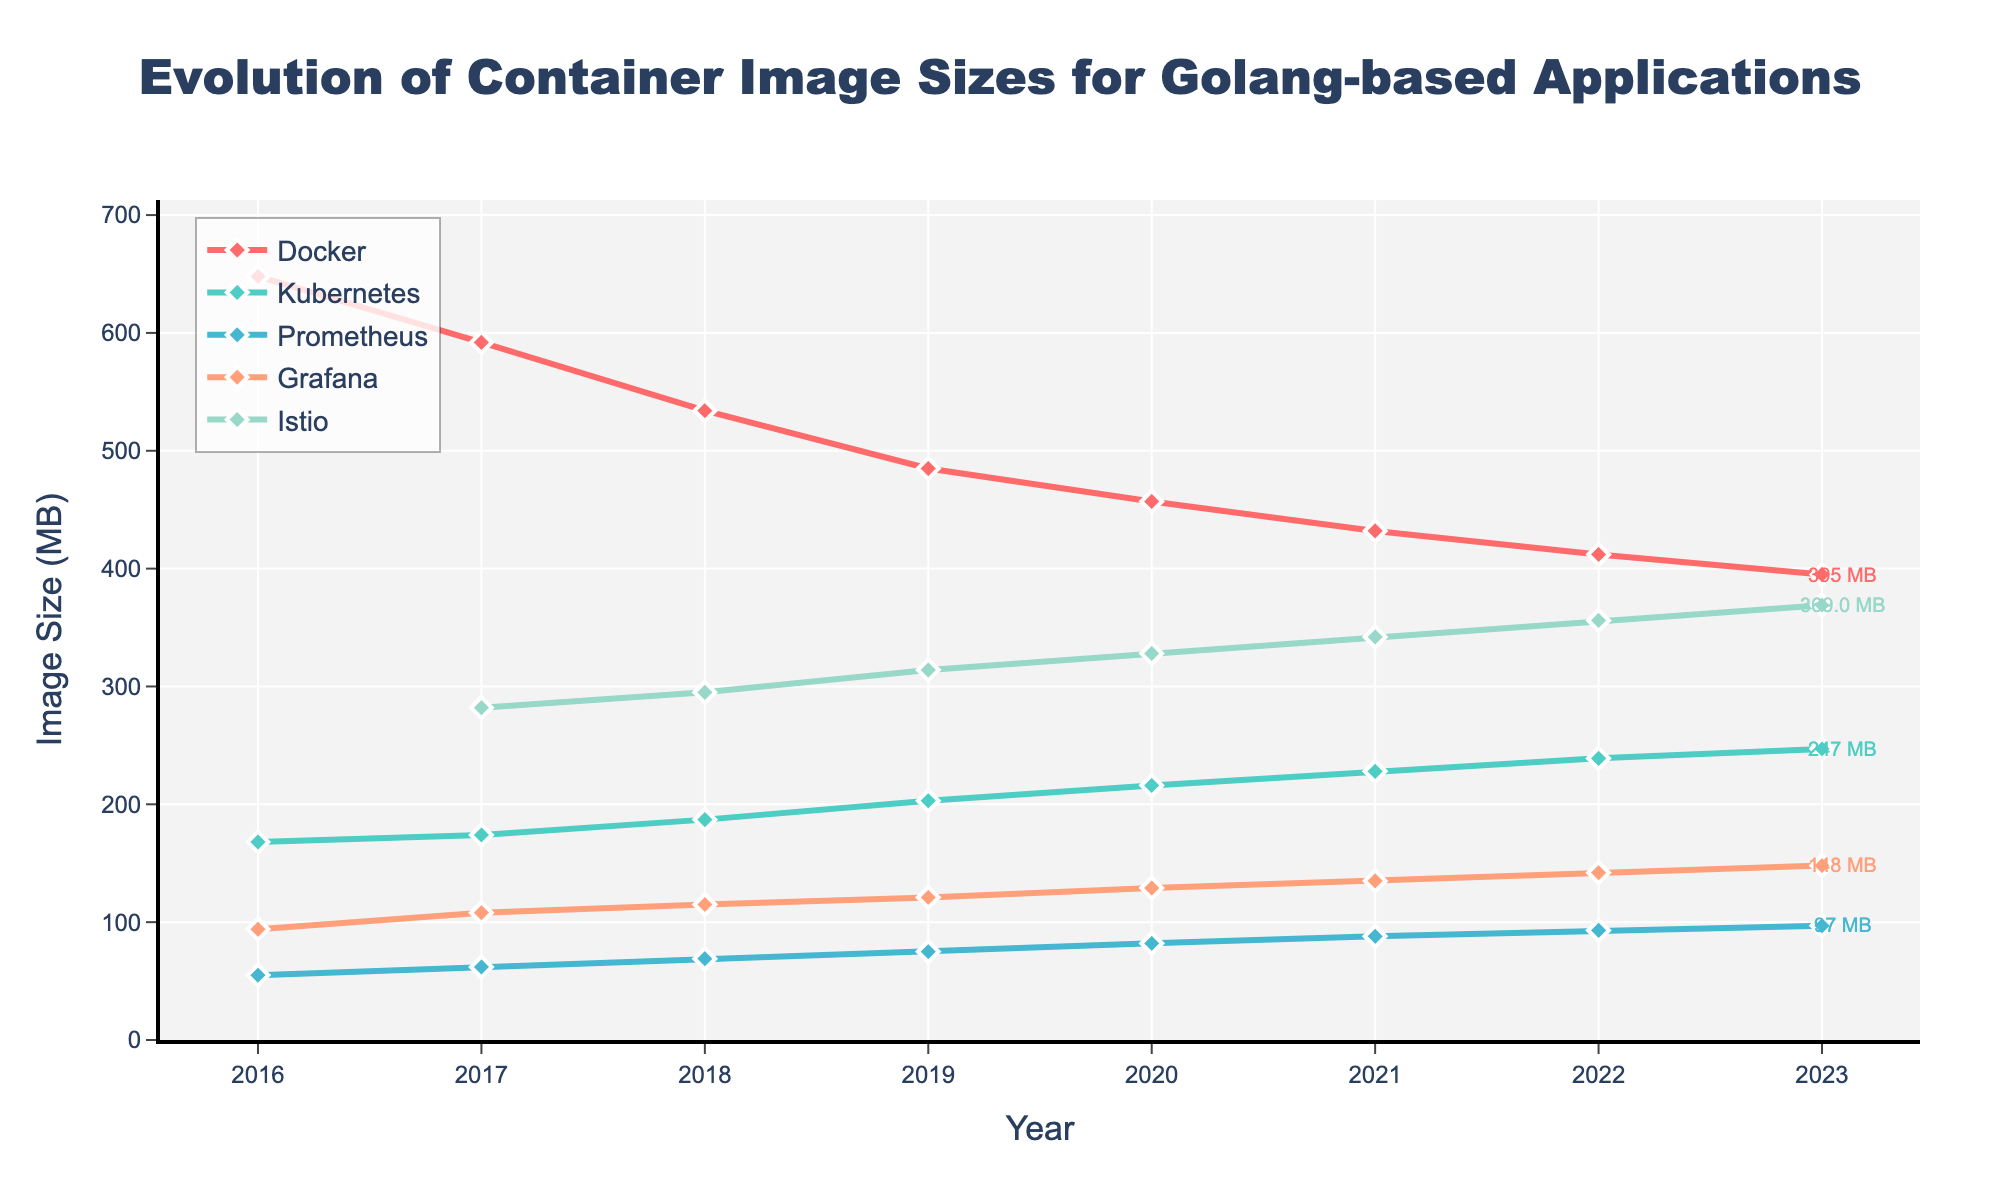Which application had the largest container image size in 2019? By looking at the plot, identify the highest point corresponding to the year 2019 across all applications. The application with the highest point in 2019 is Kubernetes with a size of 203 MB.
Answer: Kubernetes Has Docker's container image size increased or decreased from 2016 to 2023? Compare the position of Docker's line between the years 2016 and 2023. Docker's line shows a downward trend from 648 MB in 2016 to 395 MB in 2023.
Answer: Decreased In which year did Istio appear in the dataset, and what was its image size that year? Locate the first instance of Istio in the dataset by the starting point of the Istio line, which is in 2017 with an image size of 282 MB.
Answer: 2017, 282 MB Which Golang-based application had the smallest container image size in 2023? Identify the lowest point in the year 2023 across all application lines. Prometheus has the smallest container image size in 2023 with 97 MB.
Answer: Prometheus What is the approximate difference in container image size between Docker and Grafana in 2020? Look at the 2020 data points for Docker and Grafana, then calculate the difference. Docker's image size is 457 MB, and Grafana's is 129 MB, so the difference is 457 - 129 = 328 MB.
Answer: 328 MB Did the container image size for Prometheus increase consistently every year? Examine Prometheus' line on the chart to see if it consistently trends upward each year without drops. The line for Prometheus shows a consistent upward trend from 55 MB in 2016 to 97 MB in 2023.
Answer: Yes Which application exhibited the highest growth in container image size from 2016 to 2023? Calculate the difference in container image size for each application between 2016 and 2023. The growths are:
- Docker: 648 - 395 = -253 MB (decrease)
- Kubernetes: 247 - 168 = 79 MB
- Prometheus: 97 - 55 = 42 MB
- Grafana: 148 - 94 = 54 MB
- Istio: N/A to 369 = 369 MB (Istio started in 2017, so count from 2017)
The highest growth is seen in Istio with 369 MB.
Answer: Istio Compare the container image sizes of Kubernetes and Grafana in 2021. Which one was larger and by how much? Find the data points for Kubernetes and Grafana in 2021 and their respective sizes. Kubernetes is 228 MB and Grafana is 135 MB, so Kubernetes is larger by 228 - 135 = 93 MB.
Answer: Kubernetes, 93 MB What is the yearly average increase in container image size for Grafana from 2017 to 2023? Calculate the total increase between 2017 and 2023 for Grafana, then divide by the number of years. The total increase is 97 - 62 = 86 MB over 6 years, so the average increase per year is 86 / 6 ≈ 14.33 MB/year.
Answer: 14.33 MB/year By how much did the container image size of Docker change between 2017 and 2022? Subtract Docker's container image size in 2022 from its size in 2017. The sizes are 592 MB and 412 MB respectively, so the change is 592 - 412 = 180 MB, which is a decrease.
Answer: -180 MB 